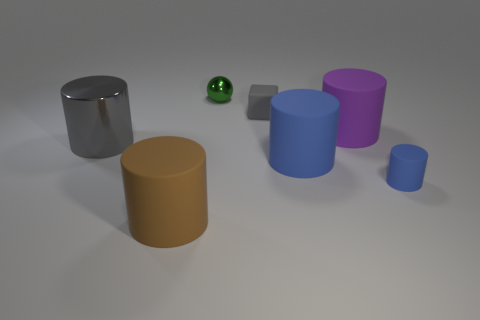There is another large blue object that is the same shape as the large metallic object; what is its material?
Your answer should be very brief. Rubber. Is the material of the cylinder that is to the left of the brown cylinder the same as the small green sphere?
Keep it short and to the point. Yes. Are there more big rubber objects in front of the small cylinder than big purple rubber objects behind the purple rubber object?
Make the answer very short. Yes. What is the size of the purple object?
Ensure brevity in your answer.  Large. There is a tiny thing that is the same material as the large gray cylinder; what shape is it?
Provide a succinct answer. Sphere. There is a tiny thing that is behind the gray matte cube; does it have the same shape as the purple thing?
Keep it short and to the point. No. What number of things are either yellow blocks or tiny green objects?
Your answer should be compact. 1. There is a big thing that is both to the left of the green sphere and behind the brown thing; what material is it made of?
Your response must be concise. Metal. Is the green ball the same size as the shiny cylinder?
Offer a very short reply. No. There is a blue thing that is on the left side of the cylinder right of the big purple cylinder; what size is it?
Offer a very short reply. Large. 